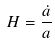<formula> <loc_0><loc_0><loc_500><loc_500>H = \frac { \dot { a } } { a }</formula> 